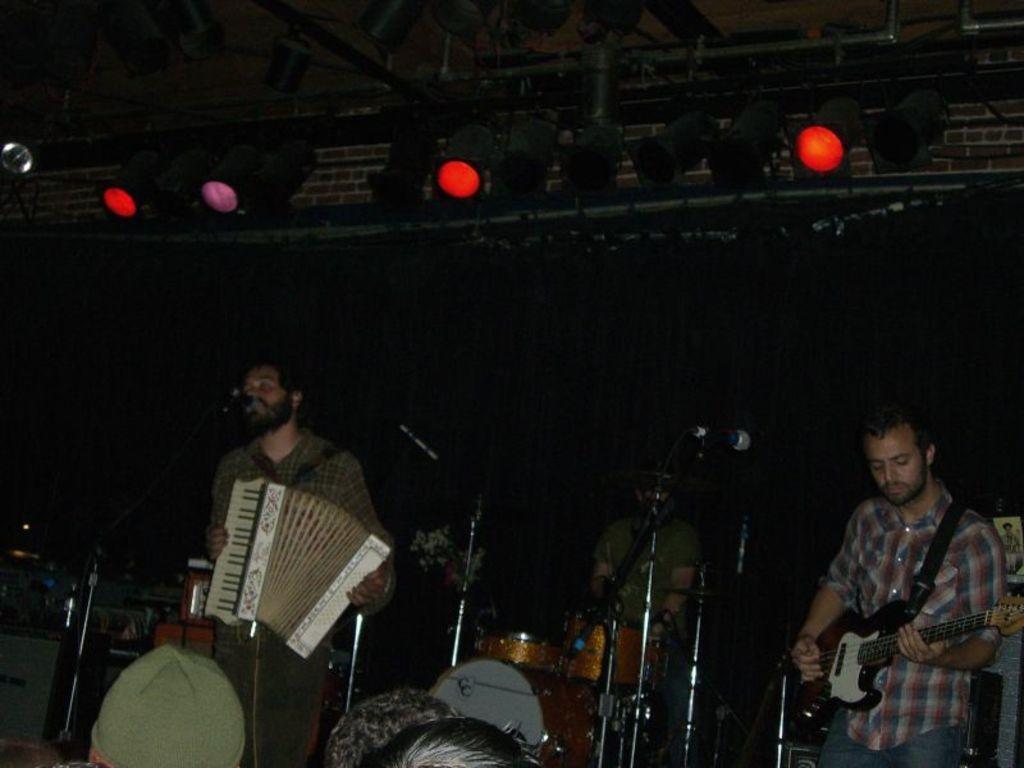How would you summarize this image in a sentence or two? In this picture, it looks like a stage. On the stage there are three people standing and holding some musical instruments. In front of the people there are microphones with stand. On the left side of the people there are some objects. At the top those are looking like lights and a truss. In front of the three people, we can see few people heads. 